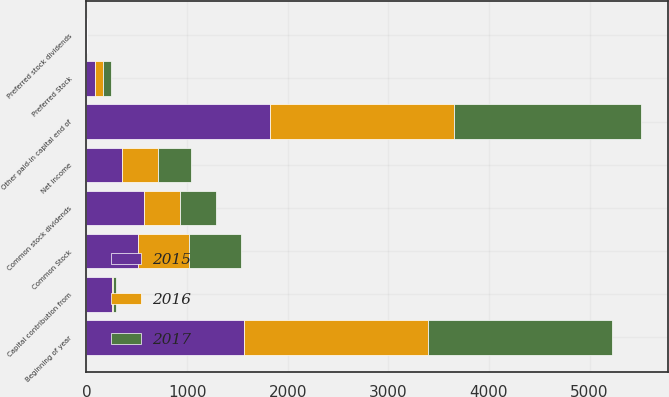Convert chart. <chart><loc_0><loc_0><loc_500><loc_500><stacked_bar_chart><ecel><fcel>Common Stock<fcel>Beginning of year<fcel>Capital contribution from<fcel>Other paid-in capital end of<fcel>Preferred Stock<fcel>Net income<fcel>Common stock dividends<fcel>Preferred stock dividends<nl><fcel>2017<fcel>511<fcel>1828<fcel>30<fcel>1858<fcel>80<fcel>326<fcel>362<fcel>3<nl><fcel>2016<fcel>511<fcel>1822<fcel>6<fcel>1828<fcel>80<fcel>360<fcel>355<fcel>3<nl><fcel>2015<fcel>511<fcel>1569<fcel>253<fcel>1822<fcel>80<fcel>355<fcel>575<fcel>3<nl></chart> 